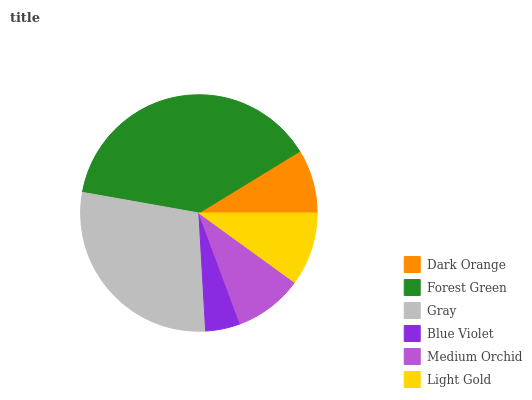Is Blue Violet the minimum?
Answer yes or no. Yes. Is Forest Green the maximum?
Answer yes or no. Yes. Is Gray the minimum?
Answer yes or no. No. Is Gray the maximum?
Answer yes or no. No. Is Forest Green greater than Gray?
Answer yes or no. Yes. Is Gray less than Forest Green?
Answer yes or no. Yes. Is Gray greater than Forest Green?
Answer yes or no. No. Is Forest Green less than Gray?
Answer yes or no. No. Is Light Gold the high median?
Answer yes or no. Yes. Is Medium Orchid the low median?
Answer yes or no. Yes. Is Medium Orchid the high median?
Answer yes or no. No. Is Blue Violet the low median?
Answer yes or no. No. 